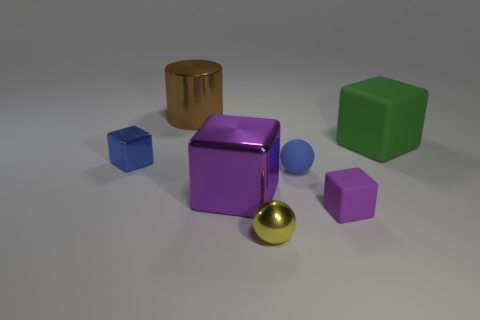Subtract all tiny blue metal cubes. How many cubes are left? 3 Subtract 2 blocks. How many blocks are left? 2 Subtract all brown balls. How many purple cubes are left? 2 Add 3 large brown objects. How many objects exist? 10 Subtract all cubes. How many objects are left? 3 Subtract all green cubes. How many cubes are left? 3 Add 4 brown metallic cylinders. How many brown metallic cylinders exist? 5 Subtract 0 gray balls. How many objects are left? 7 Subtract all gray cubes. Subtract all yellow balls. How many cubes are left? 4 Subtract all small blue objects. Subtract all purple shiny things. How many objects are left? 4 